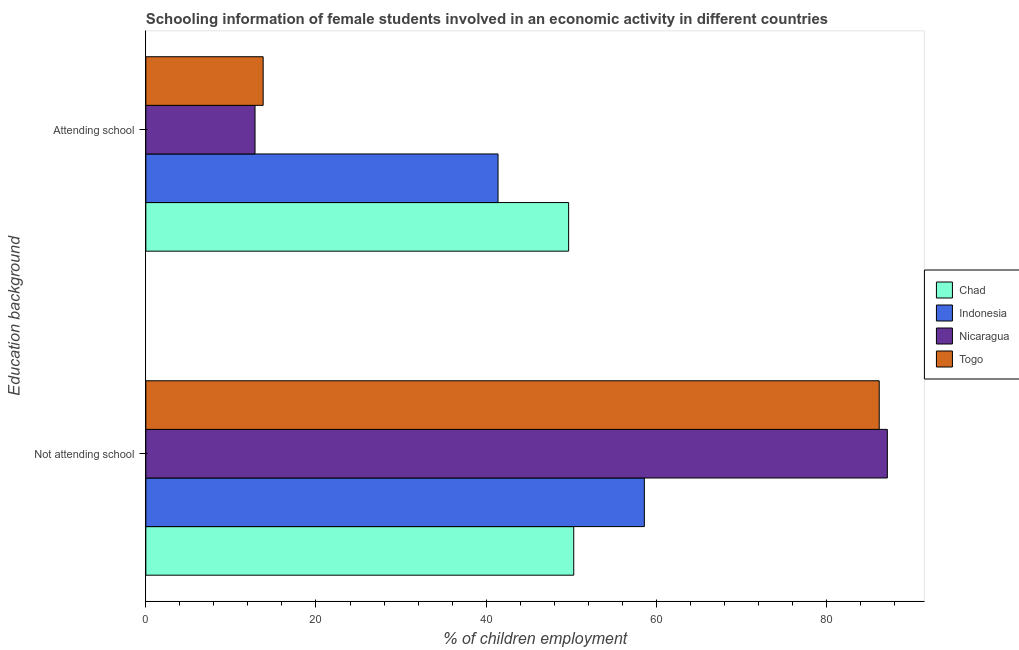How many groups of bars are there?
Ensure brevity in your answer.  2. Are the number of bars on each tick of the Y-axis equal?
Your answer should be compact. Yes. How many bars are there on the 1st tick from the bottom?
Your response must be concise. 4. What is the label of the 2nd group of bars from the top?
Ensure brevity in your answer.  Not attending school. What is the percentage of employed females who are attending school in Indonesia?
Offer a terse response. 41.4. Across all countries, what is the maximum percentage of employed females who are not attending school?
Your answer should be very brief. 87.16. Across all countries, what is the minimum percentage of employed females who are not attending school?
Your answer should be very brief. 50.3. In which country was the percentage of employed females who are not attending school maximum?
Provide a short and direct response. Nicaragua. In which country was the percentage of employed females who are not attending school minimum?
Make the answer very short. Chad. What is the total percentage of employed females who are attending school in the graph?
Offer a terse response. 117.73. What is the difference between the percentage of employed females who are attending school in Nicaragua and that in Togo?
Give a very brief answer. -0.95. What is the difference between the percentage of employed females who are not attending school in Chad and the percentage of employed females who are attending school in Togo?
Give a very brief answer. 36.51. What is the average percentage of employed females who are attending school per country?
Provide a short and direct response. 29.43. What is the difference between the percentage of employed females who are attending school and percentage of employed females who are not attending school in Togo?
Ensure brevity in your answer.  -72.42. In how many countries, is the percentage of employed females who are not attending school greater than 32 %?
Your answer should be compact. 4. What is the ratio of the percentage of employed females who are attending school in Nicaragua to that in Togo?
Offer a very short reply. 0.93. In how many countries, is the percentage of employed females who are not attending school greater than the average percentage of employed females who are not attending school taken over all countries?
Offer a very short reply. 2. What does the 3rd bar from the top in Attending school represents?
Give a very brief answer. Indonesia. What does the 1st bar from the bottom in Attending school represents?
Make the answer very short. Chad. How many bars are there?
Make the answer very short. 8. How many countries are there in the graph?
Offer a terse response. 4. Are the values on the major ticks of X-axis written in scientific E-notation?
Provide a succinct answer. No. What is the title of the graph?
Offer a terse response. Schooling information of female students involved in an economic activity in different countries. Does "Middle income" appear as one of the legend labels in the graph?
Offer a terse response. No. What is the label or title of the X-axis?
Provide a succinct answer. % of children employment. What is the label or title of the Y-axis?
Give a very brief answer. Education background. What is the % of children employment of Chad in Not attending school?
Keep it short and to the point. 50.3. What is the % of children employment in Indonesia in Not attending school?
Offer a terse response. 58.6. What is the % of children employment of Nicaragua in Not attending school?
Make the answer very short. 87.16. What is the % of children employment of Togo in Not attending school?
Offer a very short reply. 86.21. What is the % of children employment in Chad in Attending school?
Make the answer very short. 49.7. What is the % of children employment in Indonesia in Attending school?
Provide a short and direct response. 41.4. What is the % of children employment in Nicaragua in Attending school?
Give a very brief answer. 12.84. What is the % of children employment in Togo in Attending school?
Offer a terse response. 13.79. Across all Education background, what is the maximum % of children employment in Chad?
Offer a very short reply. 50.3. Across all Education background, what is the maximum % of children employment in Indonesia?
Ensure brevity in your answer.  58.6. Across all Education background, what is the maximum % of children employment of Nicaragua?
Offer a very short reply. 87.16. Across all Education background, what is the maximum % of children employment of Togo?
Keep it short and to the point. 86.21. Across all Education background, what is the minimum % of children employment in Chad?
Provide a succinct answer. 49.7. Across all Education background, what is the minimum % of children employment in Indonesia?
Provide a succinct answer. 41.4. Across all Education background, what is the minimum % of children employment in Nicaragua?
Provide a short and direct response. 12.84. Across all Education background, what is the minimum % of children employment in Togo?
Offer a very short reply. 13.79. What is the total % of children employment in Indonesia in the graph?
Offer a very short reply. 100. What is the total % of children employment in Nicaragua in the graph?
Offer a very short reply. 100. What is the difference between the % of children employment in Nicaragua in Not attending school and that in Attending school?
Give a very brief answer. 74.33. What is the difference between the % of children employment of Togo in Not attending school and that in Attending school?
Provide a short and direct response. 72.42. What is the difference between the % of children employment of Chad in Not attending school and the % of children employment of Nicaragua in Attending school?
Offer a very short reply. 37.46. What is the difference between the % of children employment of Chad in Not attending school and the % of children employment of Togo in Attending school?
Provide a short and direct response. 36.51. What is the difference between the % of children employment of Indonesia in Not attending school and the % of children employment of Nicaragua in Attending school?
Offer a terse response. 45.76. What is the difference between the % of children employment in Indonesia in Not attending school and the % of children employment in Togo in Attending school?
Keep it short and to the point. 44.81. What is the difference between the % of children employment in Nicaragua in Not attending school and the % of children employment in Togo in Attending school?
Offer a very short reply. 73.37. What is the average % of children employment of Chad per Education background?
Make the answer very short. 50. What is the average % of children employment of Indonesia per Education background?
Provide a succinct answer. 50. What is the difference between the % of children employment of Chad and % of children employment of Indonesia in Not attending school?
Keep it short and to the point. -8.3. What is the difference between the % of children employment in Chad and % of children employment in Nicaragua in Not attending school?
Make the answer very short. -36.86. What is the difference between the % of children employment in Chad and % of children employment in Togo in Not attending school?
Offer a very short reply. -35.91. What is the difference between the % of children employment in Indonesia and % of children employment in Nicaragua in Not attending school?
Ensure brevity in your answer.  -28.56. What is the difference between the % of children employment in Indonesia and % of children employment in Togo in Not attending school?
Offer a very short reply. -27.61. What is the difference between the % of children employment in Nicaragua and % of children employment in Togo in Not attending school?
Offer a very short reply. 0.95. What is the difference between the % of children employment of Chad and % of children employment of Indonesia in Attending school?
Make the answer very short. 8.3. What is the difference between the % of children employment of Chad and % of children employment of Nicaragua in Attending school?
Your answer should be compact. 36.86. What is the difference between the % of children employment of Chad and % of children employment of Togo in Attending school?
Make the answer very short. 35.91. What is the difference between the % of children employment in Indonesia and % of children employment in Nicaragua in Attending school?
Your answer should be compact. 28.56. What is the difference between the % of children employment of Indonesia and % of children employment of Togo in Attending school?
Make the answer very short. 27.61. What is the difference between the % of children employment of Nicaragua and % of children employment of Togo in Attending school?
Ensure brevity in your answer.  -0.95. What is the ratio of the % of children employment in Chad in Not attending school to that in Attending school?
Ensure brevity in your answer.  1.01. What is the ratio of the % of children employment in Indonesia in Not attending school to that in Attending school?
Keep it short and to the point. 1.42. What is the ratio of the % of children employment of Nicaragua in Not attending school to that in Attending school?
Give a very brief answer. 6.79. What is the ratio of the % of children employment of Togo in Not attending school to that in Attending school?
Provide a succinct answer. 6.25. What is the difference between the highest and the second highest % of children employment of Indonesia?
Your response must be concise. 17.2. What is the difference between the highest and the second highest % of children employment in Nicaragua?
Make the answer very short. 74.33. What is the difference between the highest and the second highest % of children employment of Togo?
Provide a short and direct response. 72.42. What is the difference between the highest and the lowest % of children employment of Chad?
Provide a short and direct response. 0.6. What is the difference between the highest and the lowest % of children employment of Nicaragua?
Make the answer very short. 74.33. What is the difference between the highest and the lowest % of children employment in Togo?
Offer a very short reply. 72.42. 